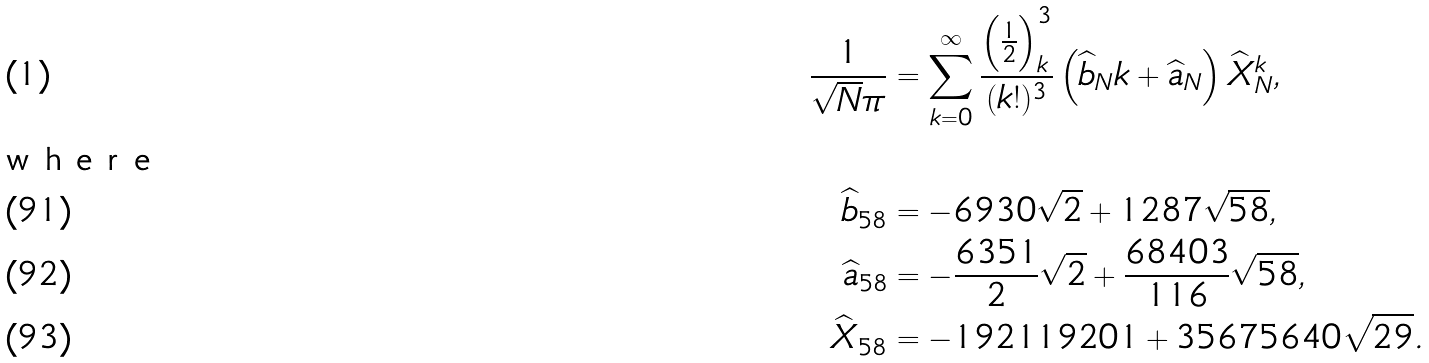Convert formula to latex. <formula><loc_0><loc_0><loc_500><loc_500>\frac { 1 } { \sqrt { N } \pi } & = \sum _ { k = 0 } ^ { \infty } \frac { \left ( \frac { 1 } { 2 } \right ) _ { k } ^ { 3 } } { ( k ! ) ^ { 3 } } \left ( \widehat { b } _ { N } k + \widehat { a } _ { N } \right ) \widehat { X } _ { N } ^ { k } , \intertext { w h e r e } \widehat { b } _ { 5 8 } & = - 6 9 3 0 \sqrt { 2 } + 1 2 8 7 \sqrt { 5 8 } , \\ \widehat { a } _ { 5 8 } & = - \frac { 6 3 5 1 } { 2 } \sqrt { 2 } + \frac { 6 8 4 0 3 } { 1 1 6 } \sqrt { 5 8 } , \\ \widehat { X } _ { 5 8 } & = - 1 9 2 1 1 9 2 0 1 + 3 5 6 7 5 6 4 0 \sqrt { 2 9 } .</formula> 